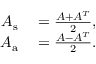Convert formula to latex. <formula><loc_0><loc_0><loc_500><loc_500>\begin{array} { r l } { A _ { s } } & = \frac { A + A ^ { T } } { 2 } , } \\ { A _ { a } } & = \frac { A - A ^ { T } } { 2 } . } \end{array}</formula> 